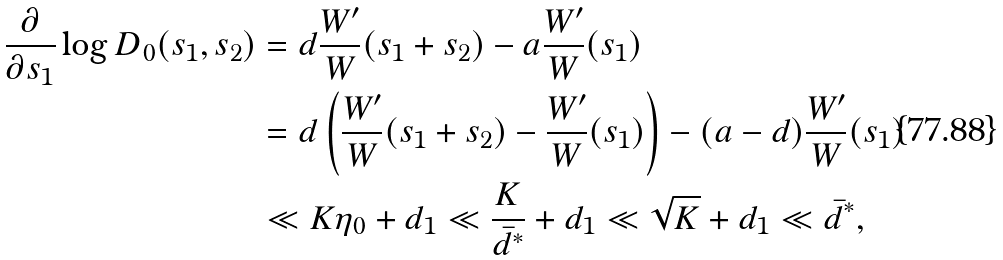Convert formula to latex. <formula><loc_0><loc_0><loc_500><loc_500>\frac { \partial } { \partial s _ { 1 } } \log D _ { 0 } ( s _ { 1 } , s _ { 2 } ) & = d \frac { W ^ { \prime } } { W } ( s _ { 1 } + s _ { 2 } ) - a \frac { W ^ { \prime } } { W } ( s _ { 1 } ) \\ & = d \left ( \frac { W ^ { \prime } } { W } ( s _ { 1 } + s _ { 2 } ) - \frac { W ^ { \prime } } { W } ( s _ { 1 } ) \right ) - ( a - d ) \frac { W ^ { \prime } } { W } ( s _ { 1 } ) \\ & \ll K \eta _ { 0 } + d _ { 1 } \ll \frac { K } { \bar { d } ^ { * } } + d _ { 1 } \ll \sqrt { K } + d _ { 1 } \ll \bar { d } ^ { * } ,</formula> 